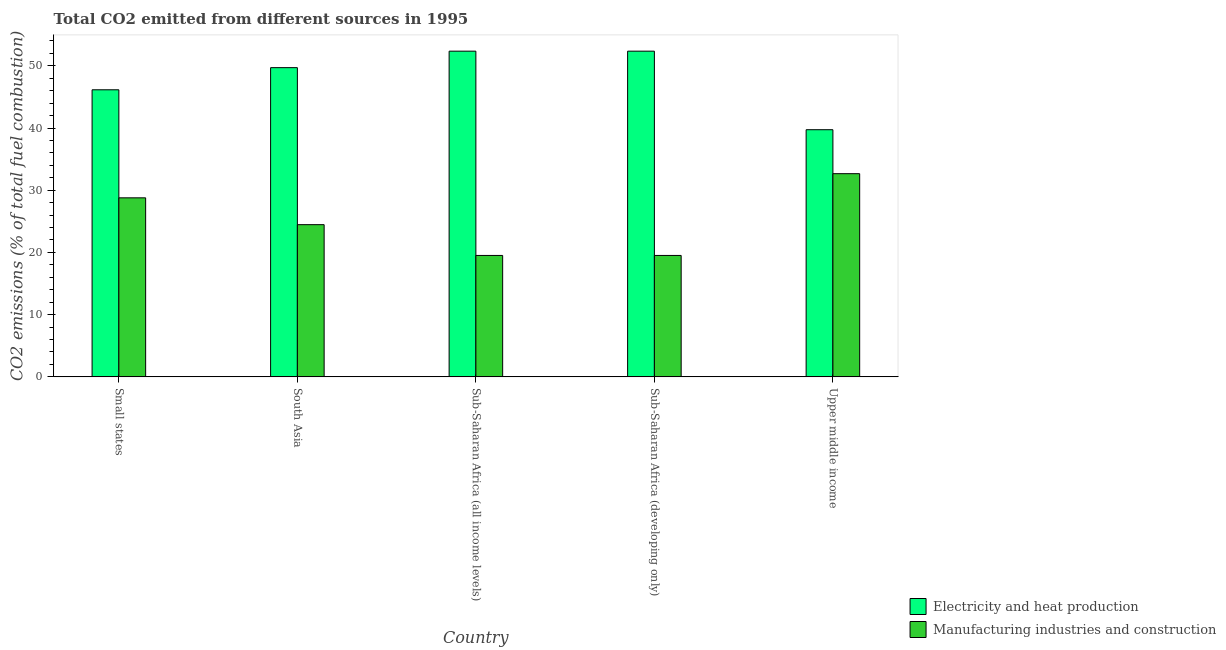Are the number of bars per tick equal to the number of legend labels?
Provide a succinct answer. Yes. How many bars are there on the 5th tick from the left?
Provide a short and direct response. 2. How many bars are there on the 1st tick from the right?
Ensure brevity in your answer.  2. What is the label of the 4th group of bars from the left?
Your answer should be compact. Sub-Saharan Africa (developing only). In how many cases, is the number of bars for a given country not equal to the number of legend labels?
Offer a terse response. 0. What is the co2 emissions due to manufacturing industries in Upper middle income?
Your response must be concise. 32.66. Across all countries, what is the maximum co2 emissions due to manufacturing industries?
Provide a short and direct response. 32.66. Across all countries, what is the minimum co2 emissions due to manufacturing industries?
Your answer should be very brief. 19.52. In which country was the co2 emissions due to electricity and heat production maximum?
Offer a terse response. Sub-Saharan Africa (all income levels). In which country was the co2 emissions due to manufacturing industries minimum?
Offer a very short reply. Sub-Saharan Africa (all income levels). What is the total co2 emissions due to manufacturing industries in the graph?
Offer a very short reply. 124.93. What is the difference between the co2 emissions due to electricity and heat production in Sub-Saharan Africa (all income levels) and the co2 emissions due to manufacturing industries in South Asia?
Keep it short and to the point. 27.89. What is the average co2 emissions due to manufacturing industries per country?
Your answer should be very brief. 24.99. What is the difference between the co2 emissions due to electricity and heat production and co2 emissions due to manufacturing industries in Sub-Saharan Africa (developing only)?
Your answer should be very brief. 32.84. In how many countries, is the co2 emissions due to manufacturing industries greater than 16 %?
Give a very brief answer. 5. What is the ratio of the co2 emissions due to electricity and heat production in South Asia to that in Sub-Saharan Africa (all income levels)?
Make the answer very short. 0.95. Is the co2 emissions due to electricity and heat production in Sub-Saharan Africa (all income levels) less than that in Upper middle income?
Your response must be concise. No. Is the difference between the co2 emissions due to manufacturing industries in South Asia and Upper middle income greater than the difference between the co2 emissions due to electricity and heat production in South Asia and Upper middle income?
Give a very brief answer. No. What is the difference between the highest and the lowest co2 emissions due to electricity and heat production?
Provide a succinct answer. 12.63. Is the sum of the co2 emissions due to electricity and heat production in Small states and South Asia greater than the maximum co2 emissions due to manufacturing industries across all countries?
Make the answer very short. Yes. What does the 2nd bar from the left in Sub-Saharan Africa (developing only) represents?
Provide a short and direct response. Manufacturing industries and construction. What does the 1st bar from the right in Upper middle income represents?
Provide a short and direct response. Manufacturing industries and construction. Are all the bars in the graph horizontal?
Provide a short and direct response. No. What is the difference between two consecutive major ticks on the Y-axis?
Your answer should be compact. 10. Are the values on the major ticks of Y-axis written in scientific E-notation?
Provide a short and direct response. No. Does the graph contain any zero values?
Keep it short and to the point. No. Does the graph contain grids?
Your answer should be very brief. No. What is the title of the graph?
Your answer should be very brief. Total CO2 emitted from different sources in 1995. Does "Commercial service exports" appear as one of the legend labels in the graph?
Your answer should be compact. No. What is the label or title of the Y-axis?
Give a very brief answer. CO2 emissions (% of total fuel combustion). What is the CO2 emissions (% of total fuel combustion) in Electricity and heat production in Small states?
Provide a short and direct response. 46.14. What is the CO2 emissions (% of total fuel combustion) of Manufacturing industries and construction in Small states?
Make the answer very short. 28.78. What is the CO2 emissions (% of total fuel combustion) in Electricity and heat production in South Asia?
Your answer should be compact. 49.7. What is the CO2 emissions (% of total fuel combustion) in Manufacturing industries and construction in South Asia?
Provide a short and direct response. 24.46. What is the CO2 emissions (% of total fuel combustion) in Electricity and heat production in Sub-Saharan Africa (all income levels)?
Provide a succinct answer. 52.35. What is the CO2 emissions (% of total fuel combustion) of Manufacturing industries and construction in Sub-Saharan Africa (all income levels)?
Your answer should be very brief. 19.52. What is the CO2 emissions (% of total fuel combustion) in Electricity and heat production in Sub-Saharan Africa (developing only)?
Provide a short and direct response. 52.35. What is the CO2 emissions (% of total fuel combustion) in Manufacturing industries and construction in Sub-Saharan Africa (developing only)?
Ensure brevity in your answer.  19.52. What is the CO2 emissions (% of total fuel combustion) of Electricity and heat production in Upper middle income?
Provide a succinct answer. 39.73. What is the CO2 emissions (% of total fuel combustion) in Manufacturing industries and construction in Upper middle income?
Your answer should be compact. 32.66. Across all countries, what is the maximum CO2 emissions (% of total fuel combustion) in Electricity and heat production?
Ensure brevity in your answer.  52.35. Across all countries, what is the maximum CO2 emissions (% of total fuel combustion) of Manufacturing industries and construction?
Your answer should be compact. 32.66. Across all countries, what is the minimum CO2 emissions (% of total fuel combustion) in Electricity and heat production?
Make the answer very short. 39.73. Across all countries, what is the minimum CO2 emissions (% of total fuel combustion) of Manufacturing industries and construction?
Your answer should be compact. 19.52. What is the total CO2 emissions (% of total fuel combustion) in Electricity and heat production in the graph?
Offer a terse response. 240.27. What is the total CO2 emissions (% of total fuel combustion) in Manufacturing industries and construction in the graph?
Give a very brief answer. 124.93. What is the difference between the CO2 emissions (% of total fuel combustion) of Electricity and heat production in Small states and that in South Asia?
Provide a short and direct response. -3.56. What is the difference between the CO2 emissions (% of total fuel combustion) of Manufacturing industries and construction in Small states and that in South Asia?
Offer a very short reply. 4.31. What is the difference between the CO2 emissions (% of total fuel combustion) of Electricity and heat production in Small states and that in Sub-Saharan Africa (all income levels)?
Your response must be concise. -6.21. What is the difference between the CO2 emissions (% of total fuel combustion) in Manufacturing industries and construction in Small states and that in Sub-Saharan Africa (all income levels)?
Give a very brief answer. 9.26. What is the difference between the CO2 emissions (% of total fuel combustion) of Electricity and heat production in Small states and that in Sub-Saharan Africa (developing only)?
Provide a short and direct response. -6.21. What is the difference between the CO2 emissions (% of total fuel combustion) of Manufacturing industries and construction in Small states and that in Sub-Saharan Africa (developing only)?
Offer a very short reply. 9.26. What is the difference between the CO2 emissions (% of total fuel combustion) in Electricity and heat production in Small states and that in Upper middle income?
Give a very brief answer. 6.42. What is the difference between the CO2 emissions (% of total fuel combustion) in Manufacturing industries and construction in Small states and that in Upper middle income?
Ensure brevity in your answer.  -3.88. What is the difference between the CO2 emissions (% of total fuel combustion) of Electricity and heat production in South Asia and that in Sub-Saharan Africa (all income levels)?
Keep it short and to the point. -2.65. What is the difference between the CO2 emissions (% of total fuel combustion) in Manufacturing industries and construction in South Asia and that in Sub-Saharan Africa (all income levels)?
Ensure brevity in your answer.  4.95. What is the difference between the CO2 emissions (% of total fuel combustion) of Electricity and heat production in South Asia and that in Sub-Saharan Africa (developing only)?
Provide a short and direct response. -2.65. What is the difference between the CO2 emissions (% of total fuel combustion) of Manufacturing industries and construction in South Asia and that in Sub-Saharan Africa (developing only)?
Offer a very short reply. 4.95. What is the difference between the CO2 emissions (% of total fuel combustion) of Electricity and heat production in South Asia and that in Upper middle income?
Give a very brief answer. 9.98. What is the difference between the CO2 emissions (% of total fuel combustion) of Manufacturing industries and construction in South Asia and that in Upper middle income?
Ensure brevity in your answer.  -8.2. What is the difference between the CO2 emissions (% of total fuel combustion) in Electricity and heat production in Sub-Saharan Africa (all income levels) and that in Upper middle income?
Ensure brevity in your answer.  12.63. What is the difference between the CO2 emissions (% of total fuel combustion) of Manufacturing industries and construction in Sub-Saharan Africa (all income levels) and that in Upper middle income?
Offer a very short reply. -13.14. What is the difference between the CO2 emissions (% of total fuel combustion) of Electricity and heat production in Sub-Saharan Africa (developing only) and that in Upper middle income?
Offer a terse response. 12.63. What is the difference between the CO2 emissions (% of total fuel combustion) of Manufacturing industries and construction in Sub-Saharan Africa (developing only) and that in Upper middle income?
Your answer should be compact. -13.14. What is the difference between the CO2 emissions (% of total fuel combustion) in Electricity and heat production in Small states and the CO2 emissions (% of total fuel combustion) in Manufacturing industries and construction in South Asia?
Give a very brief answer. 21.68. What is the difference between the CO2 emissions (% of total fuel combustion) of Electricity and heat production in Small states and the CO2 emissions (% of total fuel combustion) of Manufacturing industries and construction in Sub-Saharan Africa (all income levels)?
Make the answer very short. 26.63. What is the difference between the CO2 emissions (% of total fuel combustion) of Electricity and heat production in Small states and the CO2 emissions (% of total fuel combustion) of Manufacturing industries and construction in Sub-Saharan Africa (developing only)?
Your answer should be very brief. 26.63. What is the difference between the CO2 emissions (% of total fuel combustion) in Electricity and heat production in Small states and the CO2 emissions (% of total fuel combustion) in Manufacturing industries and construction in Upper middle income?
Make the answer very short. 13.48. What is the difference between the CO2 emissions (% of total fuel combustion) in Electricity and heat production in South Asia and the CO2 emissions (% of total fuel combustion) in Manufacturing industries and construction in Sub-Saharan Africa (all income levels)?
Your response must be concise. 30.19. What is the difference between the CO2 emissions (% of total fuel combustion) in Electricity and heat production in South Asia and the CO2 emissions (% of total fuel combustion) in Manufacturing industries and construction in Sub-Saharan Africa (developing only)?
Offer a terse response. 30.19. What is the difference between the CO2 emissions (% of total fuel combustion) in Electricity and heat production in South Asia and the CO2 emissions (% of total fuel combustion) in Manufacturing industries and construction in Upper middle income?
Provide a short and direct response. 17.04. What is the difference between the CO2 emissions (% of total fuel combustion) of Electricity and heat production in Sub-Saharan Africa (all income levels) and the CO2 emissions (% of total fuel combustion) of Manufacturing industries and construction in Sub-Saharan Africa (developing only)?
Offer a terse response. 32.84. What is the difference between the CO2 emissions (% of total fuel combustion) in Electricity and heat production in Sub-Saharan Africa (all income levels) and the CO2 emissions (% of total fuel combustion) in Manufacturing industries and construction in Upper middle income?
Offer a very short reply. 19.69. What is the difference between the CO2 emissions (% of total fuel combustion) of Electricity and heat production in Sub-Saharan Africa (developing only) and the CO2 emissions (% of total fuel combustion) of Manufacturing industries and construction in Upper middle income?
Your response must be concise. 19.69. What is the average CO2 emissions (% of total fuel combustion) in Electricity and heat production per country?
Offer a terse response. 48.05. What is the average CO2 emissions (% of total fuel combustion) of Manufacturing industries and construction per country?
Offer a very short reply. 24.99. What is the difference between the CO2 emissions (% of total fuel combustion) of Electricity and heat production and CO2 emissions (% of total fuel combustion) of Manufacturing industries and construction in Small states?
Provide a short and direct response. 17.37. What is the difference between the CO2 emissions (% of total fuel combustion) in Electricity and heat production and CO2 emissions (% of total fuel combustion) in Manufacturing industries and construction in South Asia?
Keep it short and to the point. 25.24. What is the difference between the CO2 emissions (% of total fuel combustion) in Electricity and heat production and CO2 emissions (% of total fuel combustion) in Manufacturing industries and construction in Sub-Saharan Africa (all income levels)?
Keep it short and to the point. 32.84. What is the difference between the CO2 emissions (% of total fuel combustion) in Electricity and heat production and CO2 emissions (% of total fuel combustion) in Manufacturing industries and construction in Sub-Saharan Africa (developing only)?
Give a very brief answer. 32.84. What is the difference between the CO2 emissions (% of total fuel combustion) in Electricity and heat production and CO2 emissions (% of total fuel combustion) in Manufacturing industries and construction in Upper middle income?
Your answer should be very brief. 7.07. What is the ratio of the CO2 emissions (% of total fuel combustion) in Electricity and heat production in Small states to that in South Asia?
Offer a terse response. 0.93. What is the ratio of the CO2 emissions (% of total fuel combustion) of Manufacturing industries and construction in Small states to that in South Asia?
Provide a short and direct response. 1.18. What is the ratio of the CO2 emissions (% of total fuel combustion) in Electricity and heat production in Small states to that in Sub-Saharan Africa (all income levels)?
Ensure brevity in your answer.  0.88. What is the ratio of the CO2 emissions (% of total fuel combustion) of Manufacturing industries and construction in Small states to that in Sub-Saharan Africa (all income levels)?
Offer a very short reply. 1.47. What is the ratio of the CO2 emissions (% of total fuel combustion) in Electricity and heat production in Small states to that in Sub-Saharan Africa (developing only)?
Your response must be concise. 0.88. What is the ratio of the CO2 emissions (% of total fuel combustion) of Manufacturing industries and construction in Small states to that in Sub-Saharan Africa (developing only)?
Your answer should be very brief. 1.47. What is the ratio of the CO2 emissions (% of total fuel combustion) of Electricity and heat production in Small states to that in Upper middle income?
Offer a very short reply. 1.16. What is the ratio of the CO2 emissions (% of total fuel combustion) in Manufacturing industries and construction in Small states to that in Upper middle income?
Provide a succinct answer. 0.88. What is the ratio of the CO2 emissions (% of total fuel combustion) in Electricity and heat production in South Asia to that in Sub-Saharan Africa (all income levels)?
Give a very brief answer. 0.95. What is the ratio of the CO2 emissions (% of total fuel combustion) of Manufacturing industries and construction in South Asia to that in Sub-Saharan Africa (all income levels)?
Provide a succinct answer. 1.25. What is the ratio of the CO2 emissions (% of total fuel combustion) in Electricity and heat production in South Asia to that in Sub-Saharan Africa (developing only)?
Your answer should be very brief. 0.95. What is the ratio of the CO2 emissions (% of total fuel combustion) of Manufacturing industries and construction in South Asia to that in Sub-Saharan Africa (developing only)?
Offer a terse response. 1.25. What is the ratio of the CO2 emissions (% of total fuel combustion) in Electricity and heat production in South Asia to that in Upper middle income?
Your answer should be compact. 1.25. What is the ratio of the CO2 emissions (% of total fuel combustion) of Manufacturing industries and construction in South Asia to that in Upper middle income?
Your response must be concise. 0.75. What is the ratio of the CO2 emissions (% of total fuel combustion) in Electricity and heat production in Sub-Saharan Africa (all income levels) to that in Sub-Saharan Africa (developing only)?
Provide a succinct answer. 1. What is the ratio of the CO2 emissions (% of total fuel combustion) of Electricity and heat production in Sub-Saharan Africa (all income levels) to that in Upper middle income?
Your response must be concise. 1.32. What is the ratio of the CO2 emissions (% of total fuel combustion) of Manufacturing industries and construction in Sub-Saharan Africa (all income levels) to that in Upper middle income?
Ensure brevity in your answer.  0.6. What is the ratio of the CO2 emissions (% of total fuel combustion) in Electricity and heat production in Sub-Saharan Africa (developing only) to that in Upper middle income?
Provide a succinct answer. 1.32. What is the ratio of the CO2 emissions (% of total fuel combustion) of Manufacturing industries and construction in Sub-Saharan Africa (developing only) to that in Upper middle income?
Give a very brief answer. 0.6. What is the difference between the highest and the second highest CO2 emissions (% of total fuel combustion) of Electricity and heat production?
Give a very brief answer. 0. What is the difference between the highest and the second highest CO2 emissions (% of total fuel combustion) in Manufacturing industries and construction?
Provide a short and direct response. 3.88. What is the difference between the highest and the lowest CO2 emissions (% of total fuel combustion) of Electricity and heat production?
Your answer should be compact. 12.63. What is the difference between the highest and the lowest CO2 emissions (% of total fuel combustion) in Manufacturing industries and construction?
Your answer should be compact. 13.14. 